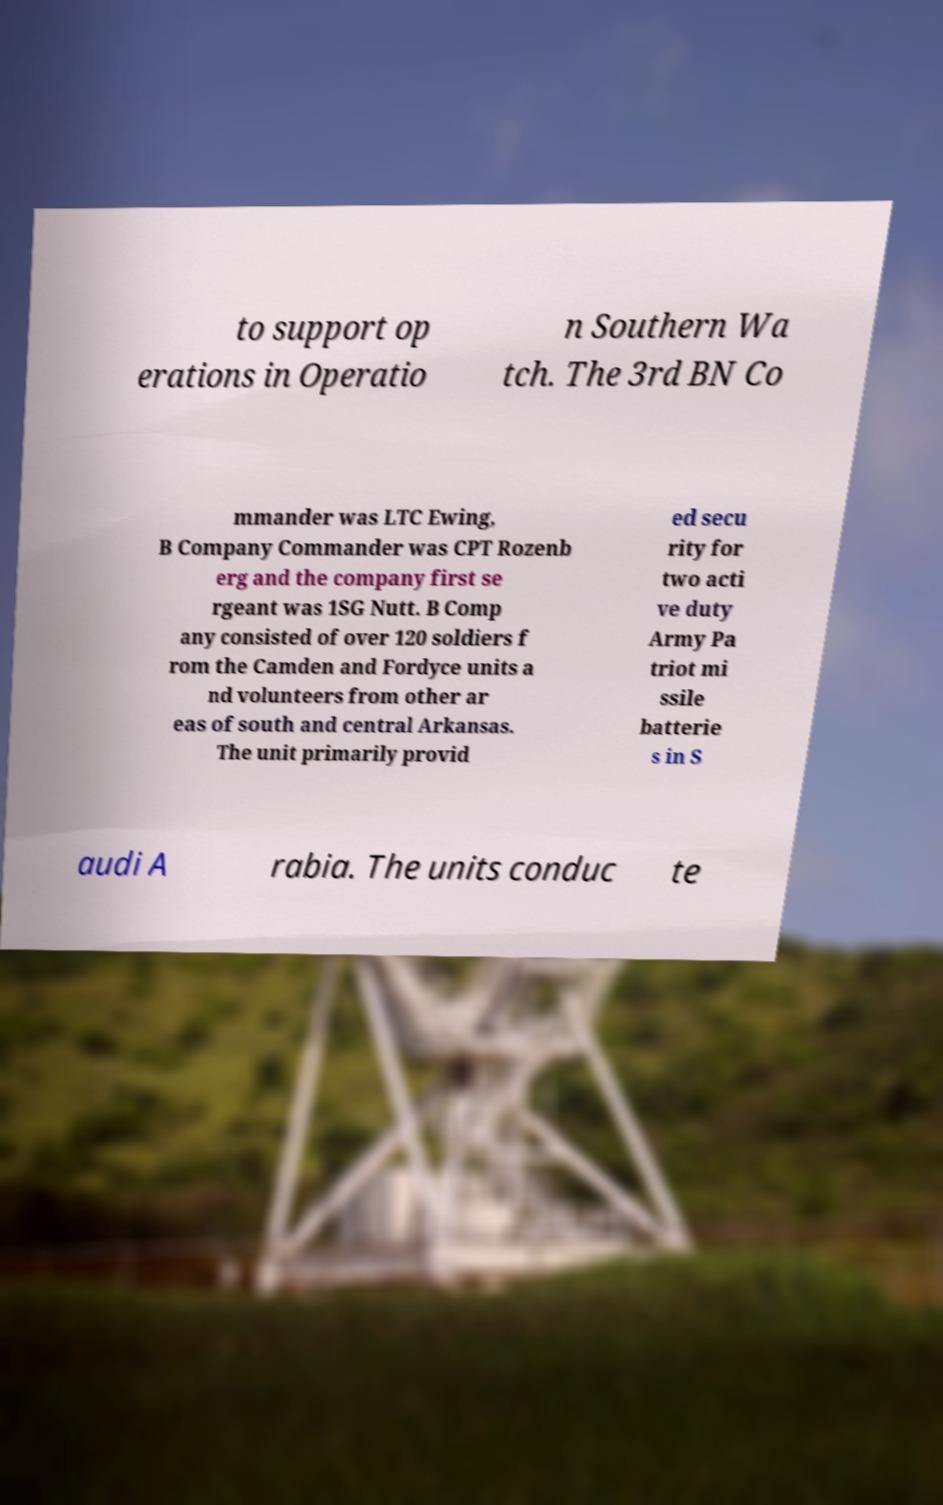Could you assist in decoding the text presented in this image and type it out clearly? to support op erations in Operatio n Southern Wa tch. The 3rd BN Co mmander was LTC Ewing, B Company Commander was CPT Rozenb erg and the company first se rgeant was 1SG Nutt. B Comp any consisted of over 120 soldiers f rom the Camden and Fordyce units a nd volunteers from other ar eas of south and central Arkansas. The unit primarily provid ed secu rity for two acti ve duty Army Pa triot mi ssile batterie s in S audi A rabia. The units conduc te 